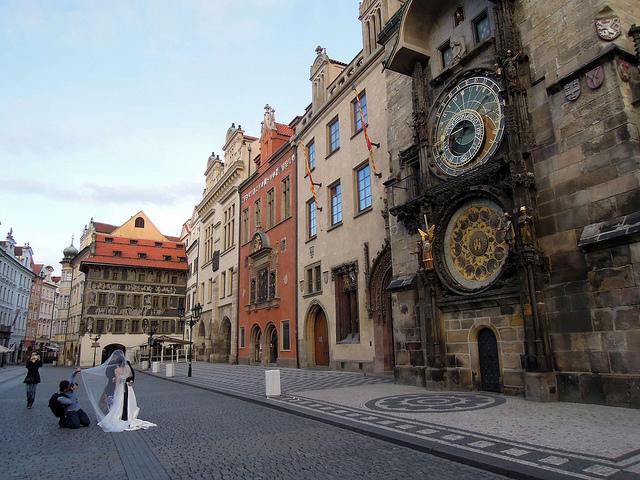Where is the clock?
Write a very short answer. On building. What event has likely just taken place?
Keep it brief. Wedding. How many people are visible?
Write a very short answer. 3. What type of building is the clock in?
Be succinct. Museum. Is this a block in the USA?
Be succinct. No. What year is on the rounded sign?
Short answer required. No year. What is the clock for?
Quick response, please. Telling time. Did Rapunzel let down her hair from one of these?
Keep it brief. No. 